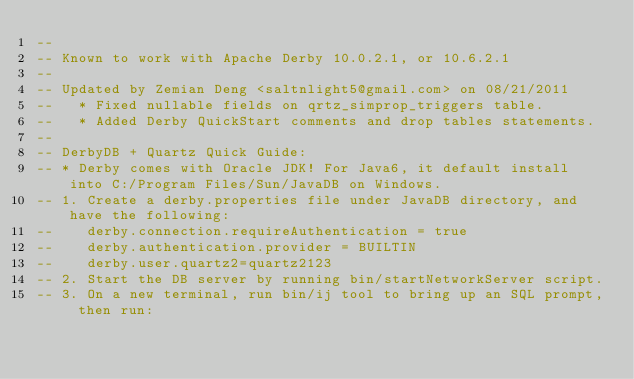<code> <loc_0><loc_0><loc_500><loc_500><_SQL_>-- 
-- Known to work with Apache Derby 10.0.2.1, or 10.6.2.1
--
-- Updated by Zemian Deng <saltnlight5@gmail.com> on 08/21/2011
--   * Fixed nullable fields on qrtz_simprop_triggers table. 
--   * Added Derby QuickStart comments and drop tables statements.
--
-- DerbyDB + Quartz Quick Guide:
-- * Derby comes with Oracle JDK! For Java6, it default install into C:/Program Files/Sun/JavaDB on Windows.
-- 1. Create a derby.properties file under JavaDB directory, and have the following:
--    derby.connection.requireAuthentication = true
--    derby.authentication.provider = BUILTIN
--    derby.user.quartz2=quartz2123
-- 2. Start the DB server by running bin/startNetworkServer script.
-- 3. On a new terminal, run bin/ij tool to bring up an SQL prompt, then run:</code> 